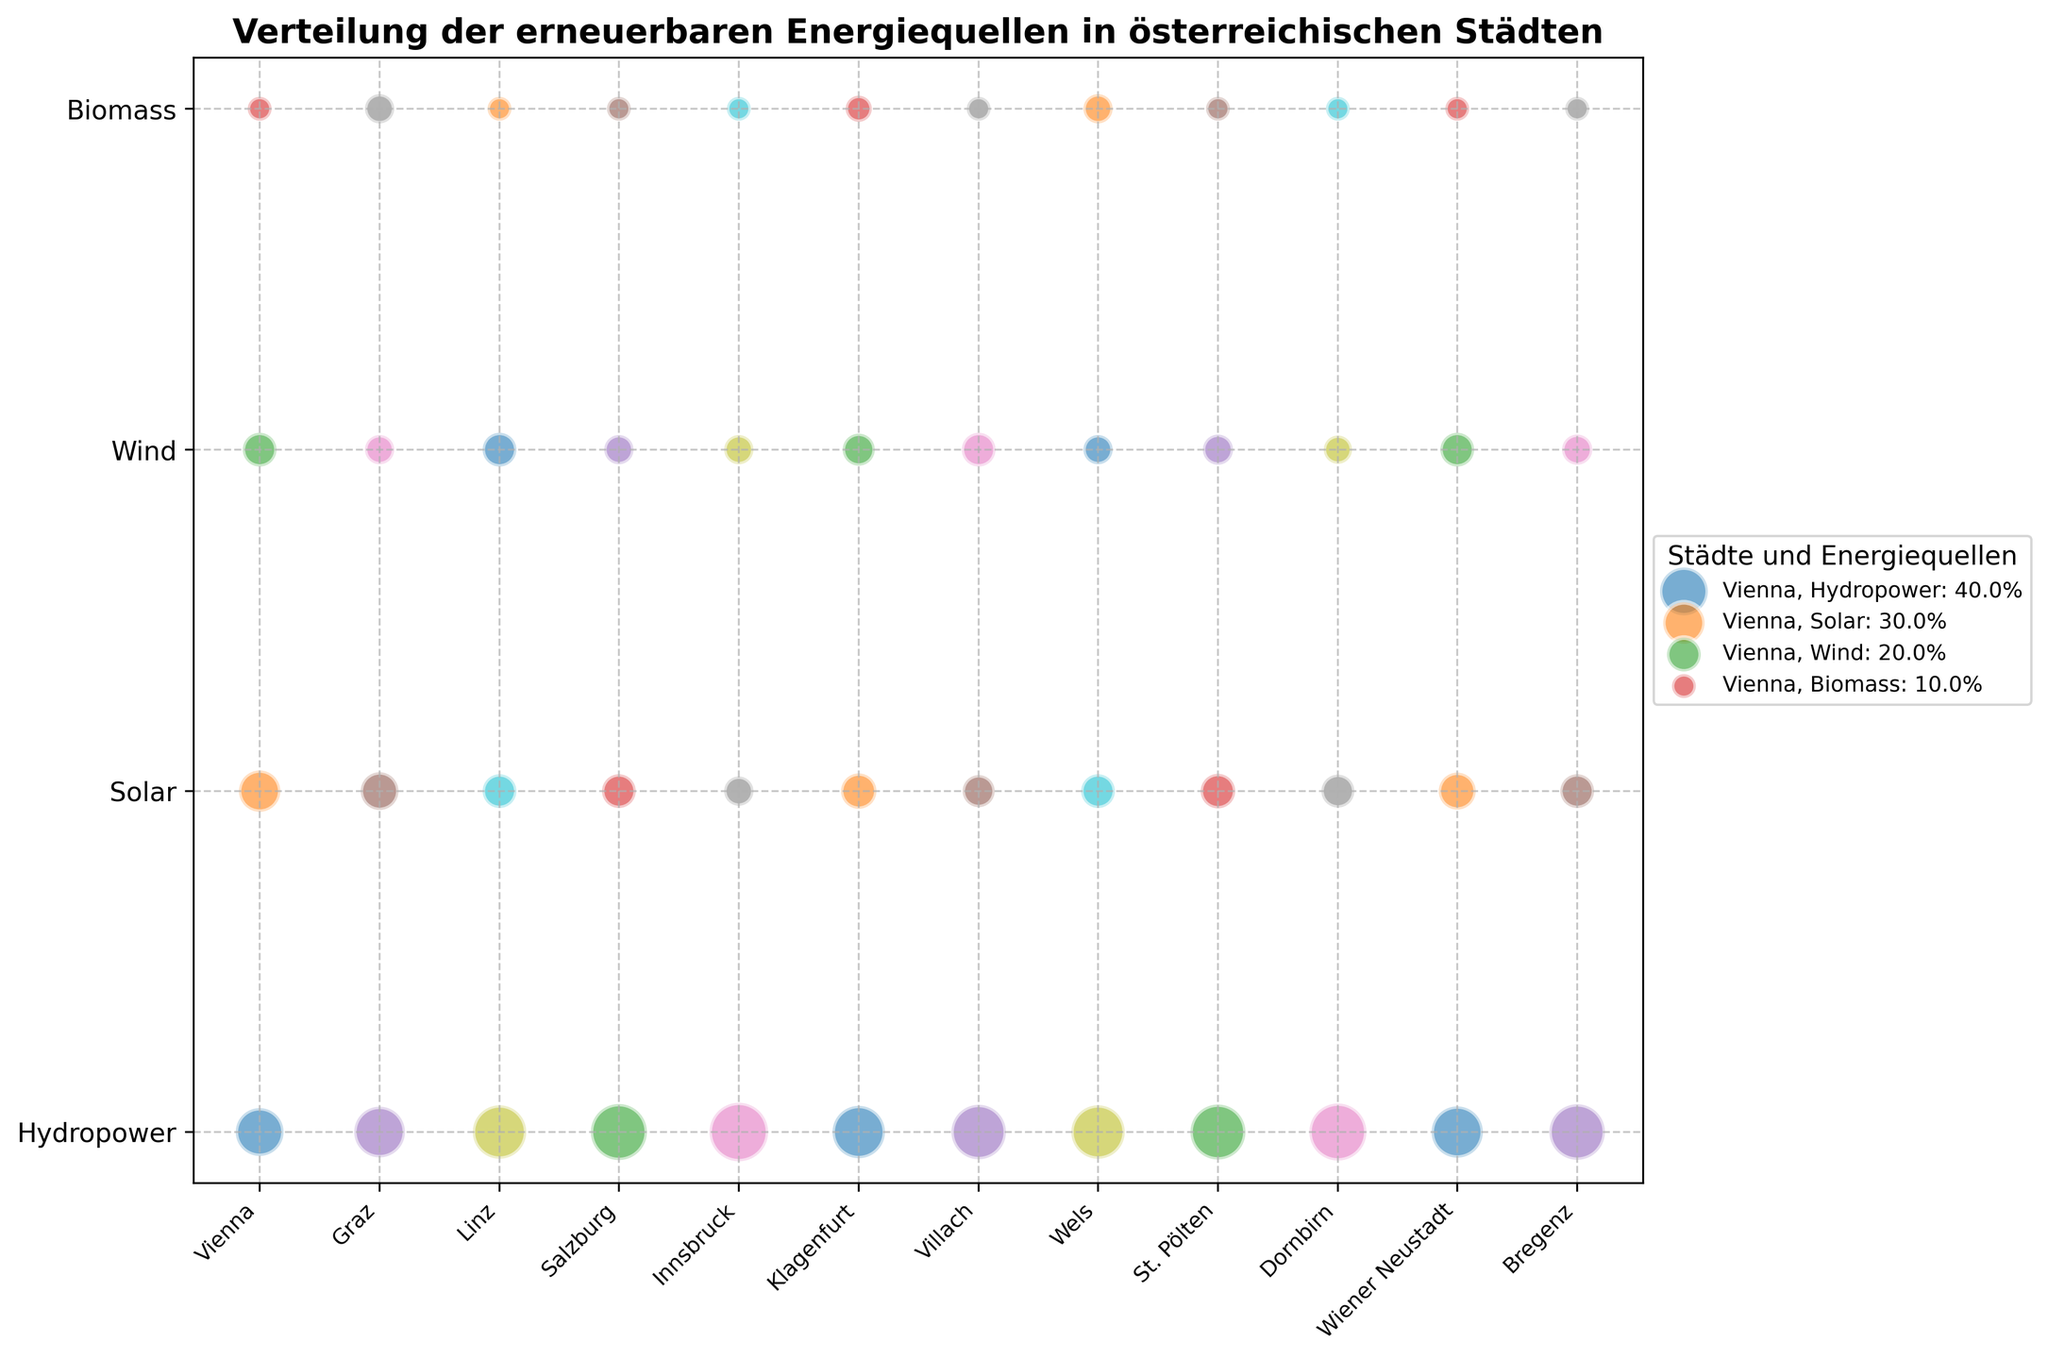Which city has the highest percentage of hydropower usage? Identify the hydropower percentages on the y-axis and find the city name corresponding to the largest bubble.
Answer: Innsbruck What is the total percentage of renewable energy sources used in Graz? Sum the percentages for all energy sources in Graz: Hydropower (45) + Solar (25) + Wind (15) + Biomass (15) = 45 + 25 + 15 + 15
Answer: 100% Compare the solar energy usage between Vienna and Klagenfurt – which city uses more? Locate the size of the bubbles for solar energy for both cities and compare: Vienna (30) vs Klagenfurt (22).
Answer: Vienna Which energy source has the most uniform distribution across all cities? Examine the bubble sizes for each energy source across different cities. Biomass has similar-sized bubbles in all cities.
Answer: Biomass What is the average percentage of wind energy in the listed cities? Identify wind energy percentages for each city and calculate their average: (20 + 15 + 20 + 15 + 15 + 18 + 20 + 15 + 16 + 14 + 20 + 16) / 12
Answer: 17.08% By how many percent does Linz's hydropower percentage exceed Vienna's hydropower percentage? Find hydropower percentages for Linz (50) and Vienna (40) and subtract to find the difference: 50 - 40
Answer: 10% Which city has the smallest percentage of biomass energy? Identify the size of the bubbles for biomass energy in all cities and find the smallest one. All cities except Graz and Wels have 10%. Since Graz and Wels have 15%, biomass usage is the smallest for all the other cities with 10%.
Answer: All cities except Graz and Wels Which city has the second-highest percentage of solar energy? Look for the second-largest bubble size for solar energy. The largest is Vienna (30), the second largest is Klagenfurt (22).
Answer: Klagenfurt Compare wind energy usage between Villach and Wels – are they used equally? Check the wind energy usage percentages for both cities: Villach (20) and Wels (15).
Answer: No Which city has similar percentages for both hydropower and solar energy? Identify the cities where the bubbles for hydropower and solar energy are close in size. Graz has hydropower (45) and solar (25), with the least variation among other cities.
Answer: Graz 